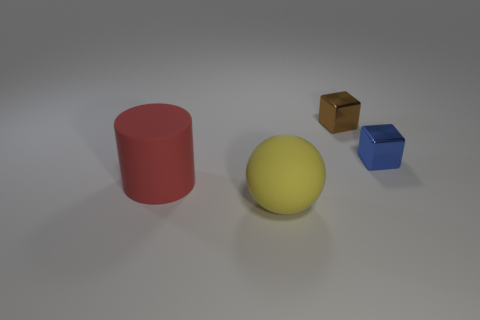Is there a small blue shiny thing that has the same shape as the small brown object?
Your answer should be very brief. Yes. There is a brown shiny object; is it the same shape as the thing that is in front of the red matte cylinder?
Provide a succinct answer. No. What number of spheres are either large red objects or blue things?
Your response must be concise. 0. The big red matte thing that is in front of the blue object has what shape?
Provide a succinct answer. Cylinder. How many red objects have the same material as the small brown block?
Keep it short and to the point. 0. Are there fewer brown metallic things that are left of the big red rubber object than big red rubber cylinders?
Provide a short and direct response. Yes. What size is the object left of the big thing that is on the right side of the large red rubber cylinder?
Give a very brief answer. Large. Does the large rubber sphere have the same color as the shiny block in front of the brown metal object?
Your answer should be very brief. No. What material is the blue object that is the same size as the brown metal object?
Offer a very short reply. Metal. Is the number of red cylinders that are in front of the large red object less than the number of blue things right of the tiny blue metallic cube?
Offer a terse response. No. 